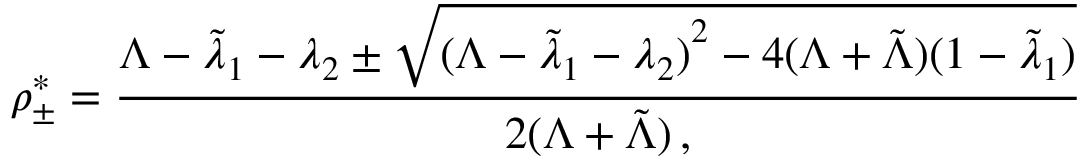Convert formula to latex. <formula><loc_0><loc_0><loc_500><loc_500>\rho _ { \pm } ^ { * } = \frac { \Lambda - \tilde { \lambda } _ { 1 } - \lambda _ { 2 } \pm \sqrt { { ( \Lambda - \tilde { \lambda } _ { 1 } - \lambda _ { 2 } ) } ^ { 2 } - 4 ( \Lambda + \tilde { \Lambda } ) ( 1 - \tilde { \lambda } _ { 1 } ) } } { 2 ( \Lambda + \tilde { \Lambda } ) \, , }</formula> 